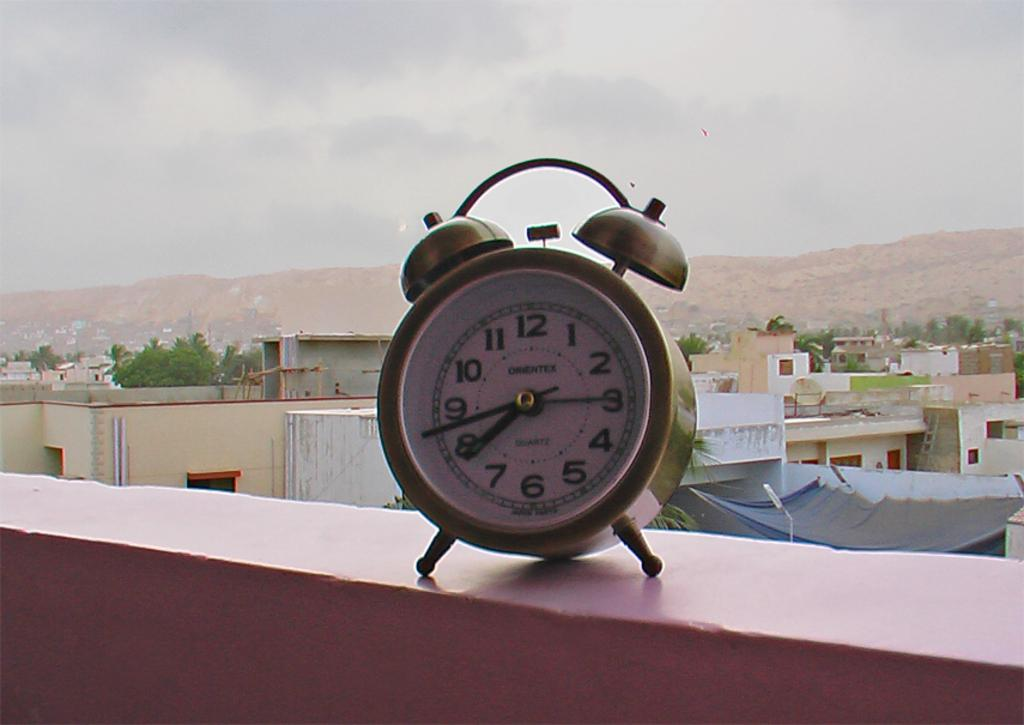<image>
Share a concise interpretation of the image provided. A brass colored alarm clock showing 7:43 is sitting on a balcony. 